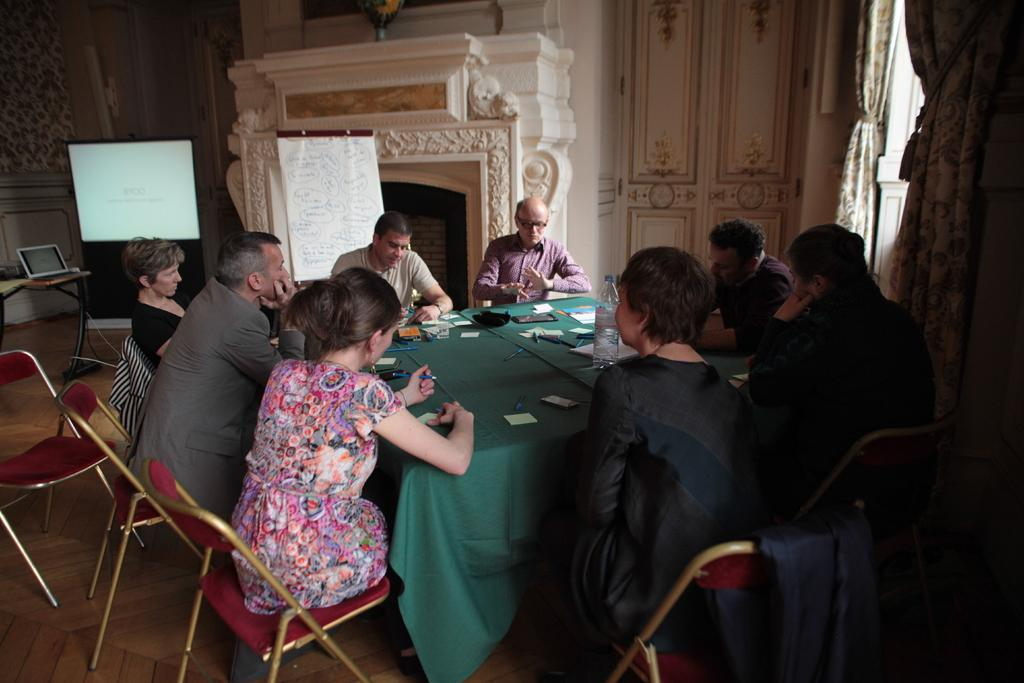Who or what can be seen in the image? There are people in the image. What are the people doing in the image? The people are sitting on chairs. What type of branch can be seen growing from the chair in the image? There is no branch growing from the chair in the image; it is a chair for sitting. 